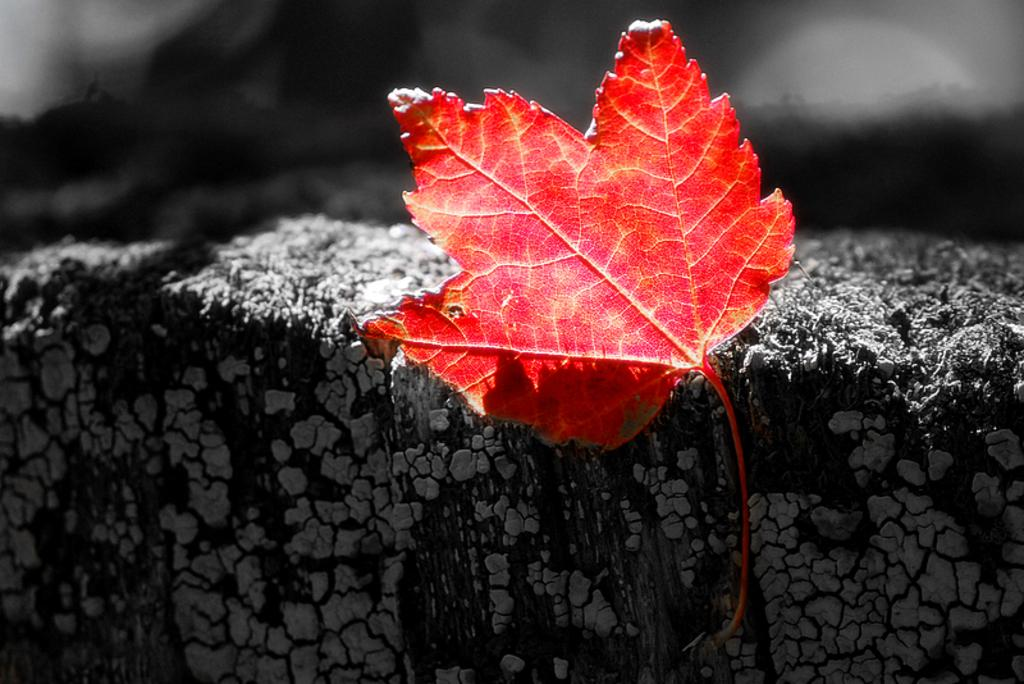What color is the leaf in the image? The leaf in the image is red. Where is the leaf located in the image? The leaf is on a surface that resembles a wall. How would you describe the background of the image? The background of the image is dark and blurred. Is there a crown made of flesh visible in the image? No, there is no crown made of flesh present in the image. 